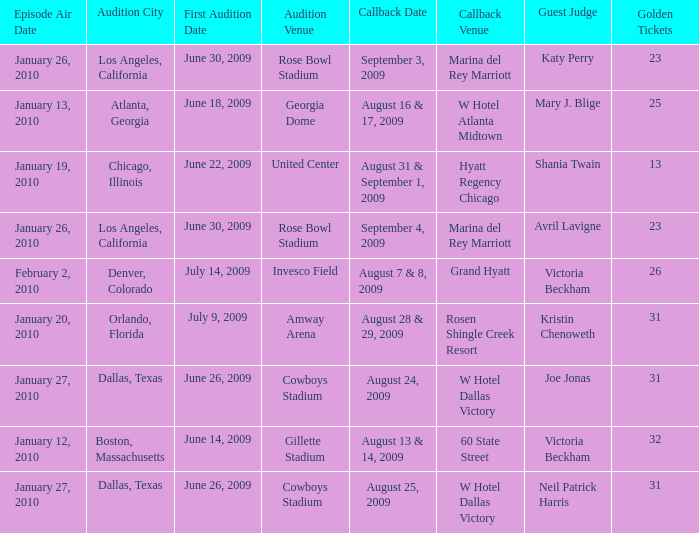Name the golden ticket for invesco field 26.0. Parse the table in full. {'header': ['Episode Air Date', 'Audition City', 'First Audition Date', 'Audition Venue', 'Callback Date', 'Callback Venue', 'Guest Judge', 'Golden Tickets'], 'rows': [['January 26, 2010', 'Los Angeles, California', 'June 30, 2009', 'Rose Bowl Stadium', 'September 3, 2009', 'Marina del Rey Marriott', 'Katy Perry', '23'], ['January 13, 2010', 'Atlanta, Georgia', 'June 18, 2009', 'Georgia Dome', 'August 16 & 17, 2009', 'W Hotel Atlanta Midtown', 'Mary J. Blige', '25'], ['January 19, 2010', 'Chicago, Illinois', 'June 22, 2009', 'United Center', 'August 31 & September 1, 2009', 'Hyatt Regency Chicago', 'Shania Twain', '13'], ['January 26, 2010', 'Los Angeles, California', 'June 30, 2009', 'Rose Bowl Stadium', 'September 4, 2009', 'Marina del Rey Marriott', 'Avril Lavigne', '23'], ['February 2, 2010', 'Denver, Colorado', 'July 14, 2009', 'Invesco Field', 'August 7 & 8, 2009', 'Grand Hyatt', 'Victoria Beckham', '26'], ['January 20, 2010', 'Orlando, Florida', 'July 9, 2009', 'Amway Arena', 'August 28 & 29, 2009', 'Rosen Shingle Creek Resort', 'Kristin Chenoweth', '31'], ['January 27, 2010', 'Dallas, Texas', 'June 26, 2009', 'Cowboys Stadium', 'August 24, 2009', 'W Hotel Dallas Victory', 'Joe Jonas', '31'], ['January 12, 2010', 'Boston, Massachusetts', 'June 14, 2009', 'Gillette Stadium', 'August 13 & 14, 2009', '60 State Street', 'Victoria Beckham', '32'], ['January 27, 2010', 'Dallas, Texas', 'June 26, 2009', 'Cowboys Stadium', 'August 25, 2009', 'W Hotel Dallas Victory', 'Neil Patrick Harris', '31']]} 